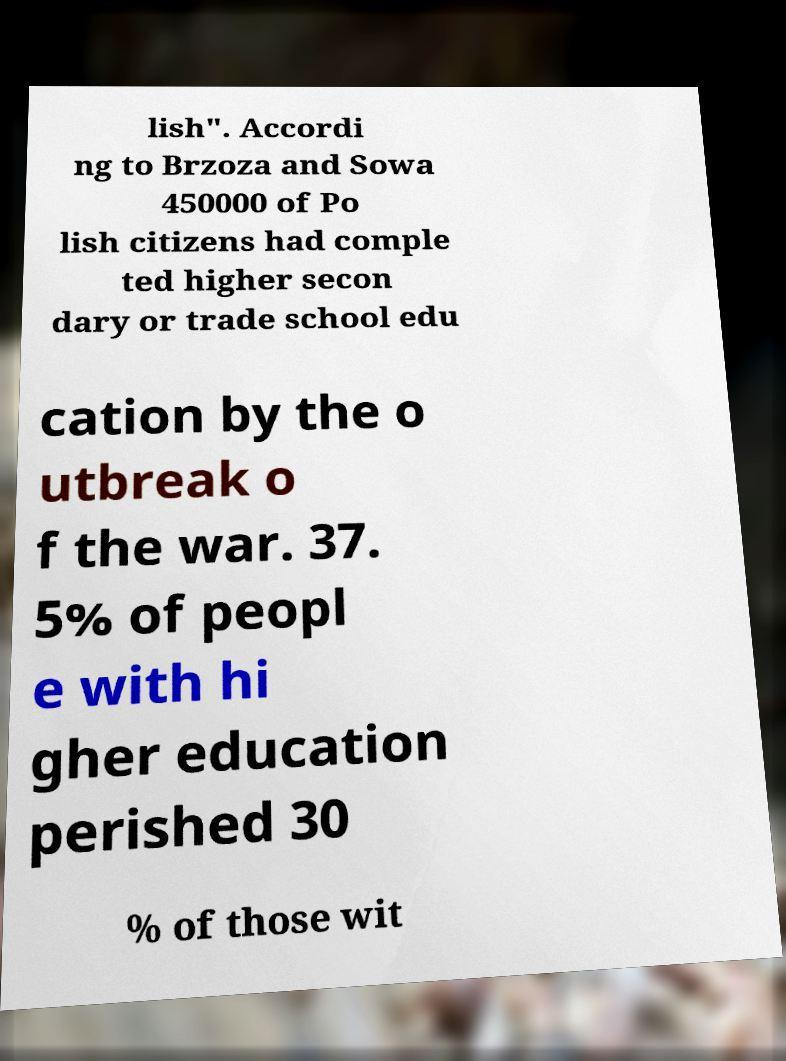Can you accurately transcribe the text from the provided image for me? lish". Accordi ng to Brzoza and Sowa 450000 of Po lish citizens had comple ted higher secon dary or trade school edu cation by the o utbreak o f the war. 37. 5% of peopl e with hi gher education perished 30 % of those wit 